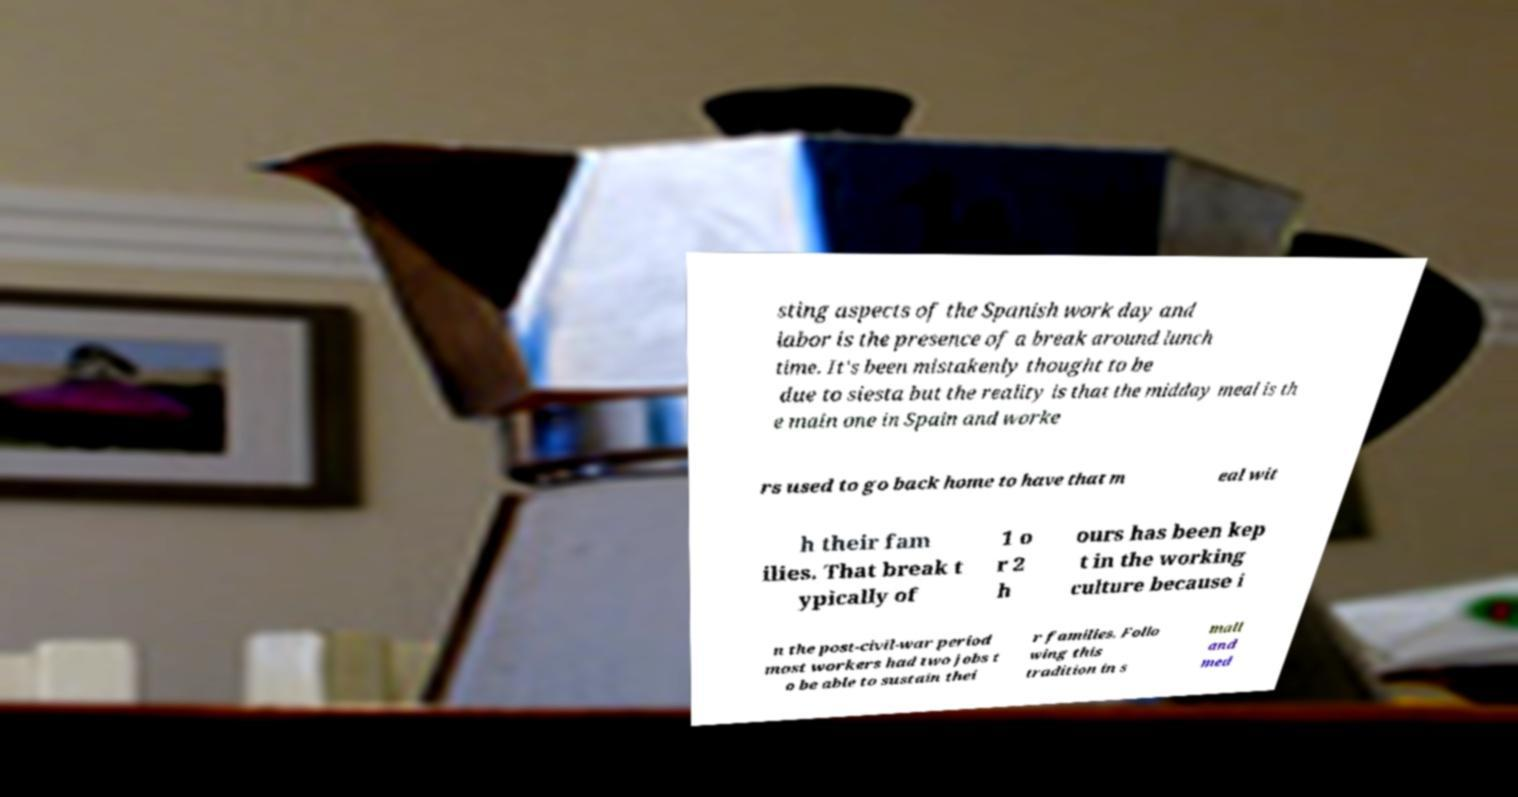For documentation purposes, I need the text within this image transcribed. Could you provide that? sting aspects of the Spanish work day and labor is the presence of a break around lunch time. It's been mistakenly thought to be due to siesta but the reality is that the midday meal is th e main one in Spain and worke rs used to go back home to have that m eal wit h their fam ilies. That break t ypically of 1 o r 2 h ours has been kep t in the working culture because i n the post-civil-war period most workers had two jobs t o be able to sustain thei r families. Follo wing this tradition in s mall and med 